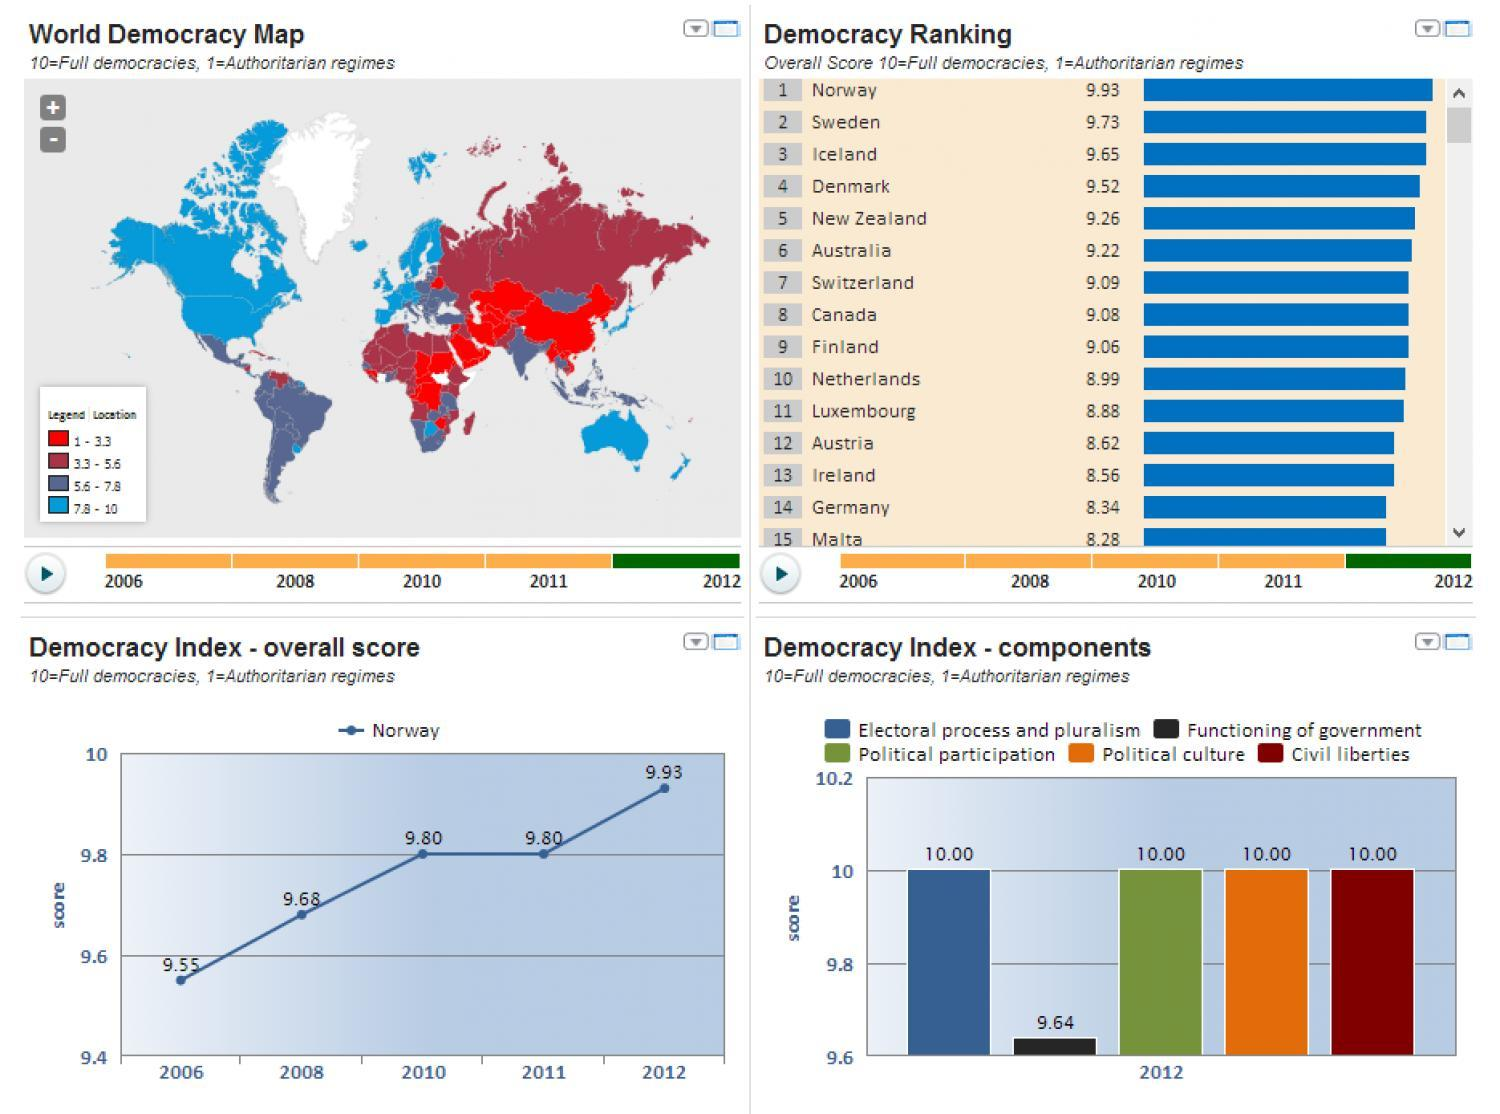in which year democracy index of Norway remain unchanged from previous year?
Answer the question with a short phrase. 2011 what is the score for political culture in 2012 according to the bar chart? 10 what is the score for civil liberties in 2012 according to the bar chart? 10 what is the score for functioning of government in 2012 according to the bar chart? 9.64 which country has fifth highest ranking in democracy in 2012? New Zealand which country has second highest ranking in democracy in 2012? sweden which country has third highest ranking in democracy in 2012? Iceland which country has 10th highest ranking in democracy in 2012? Netherlands 